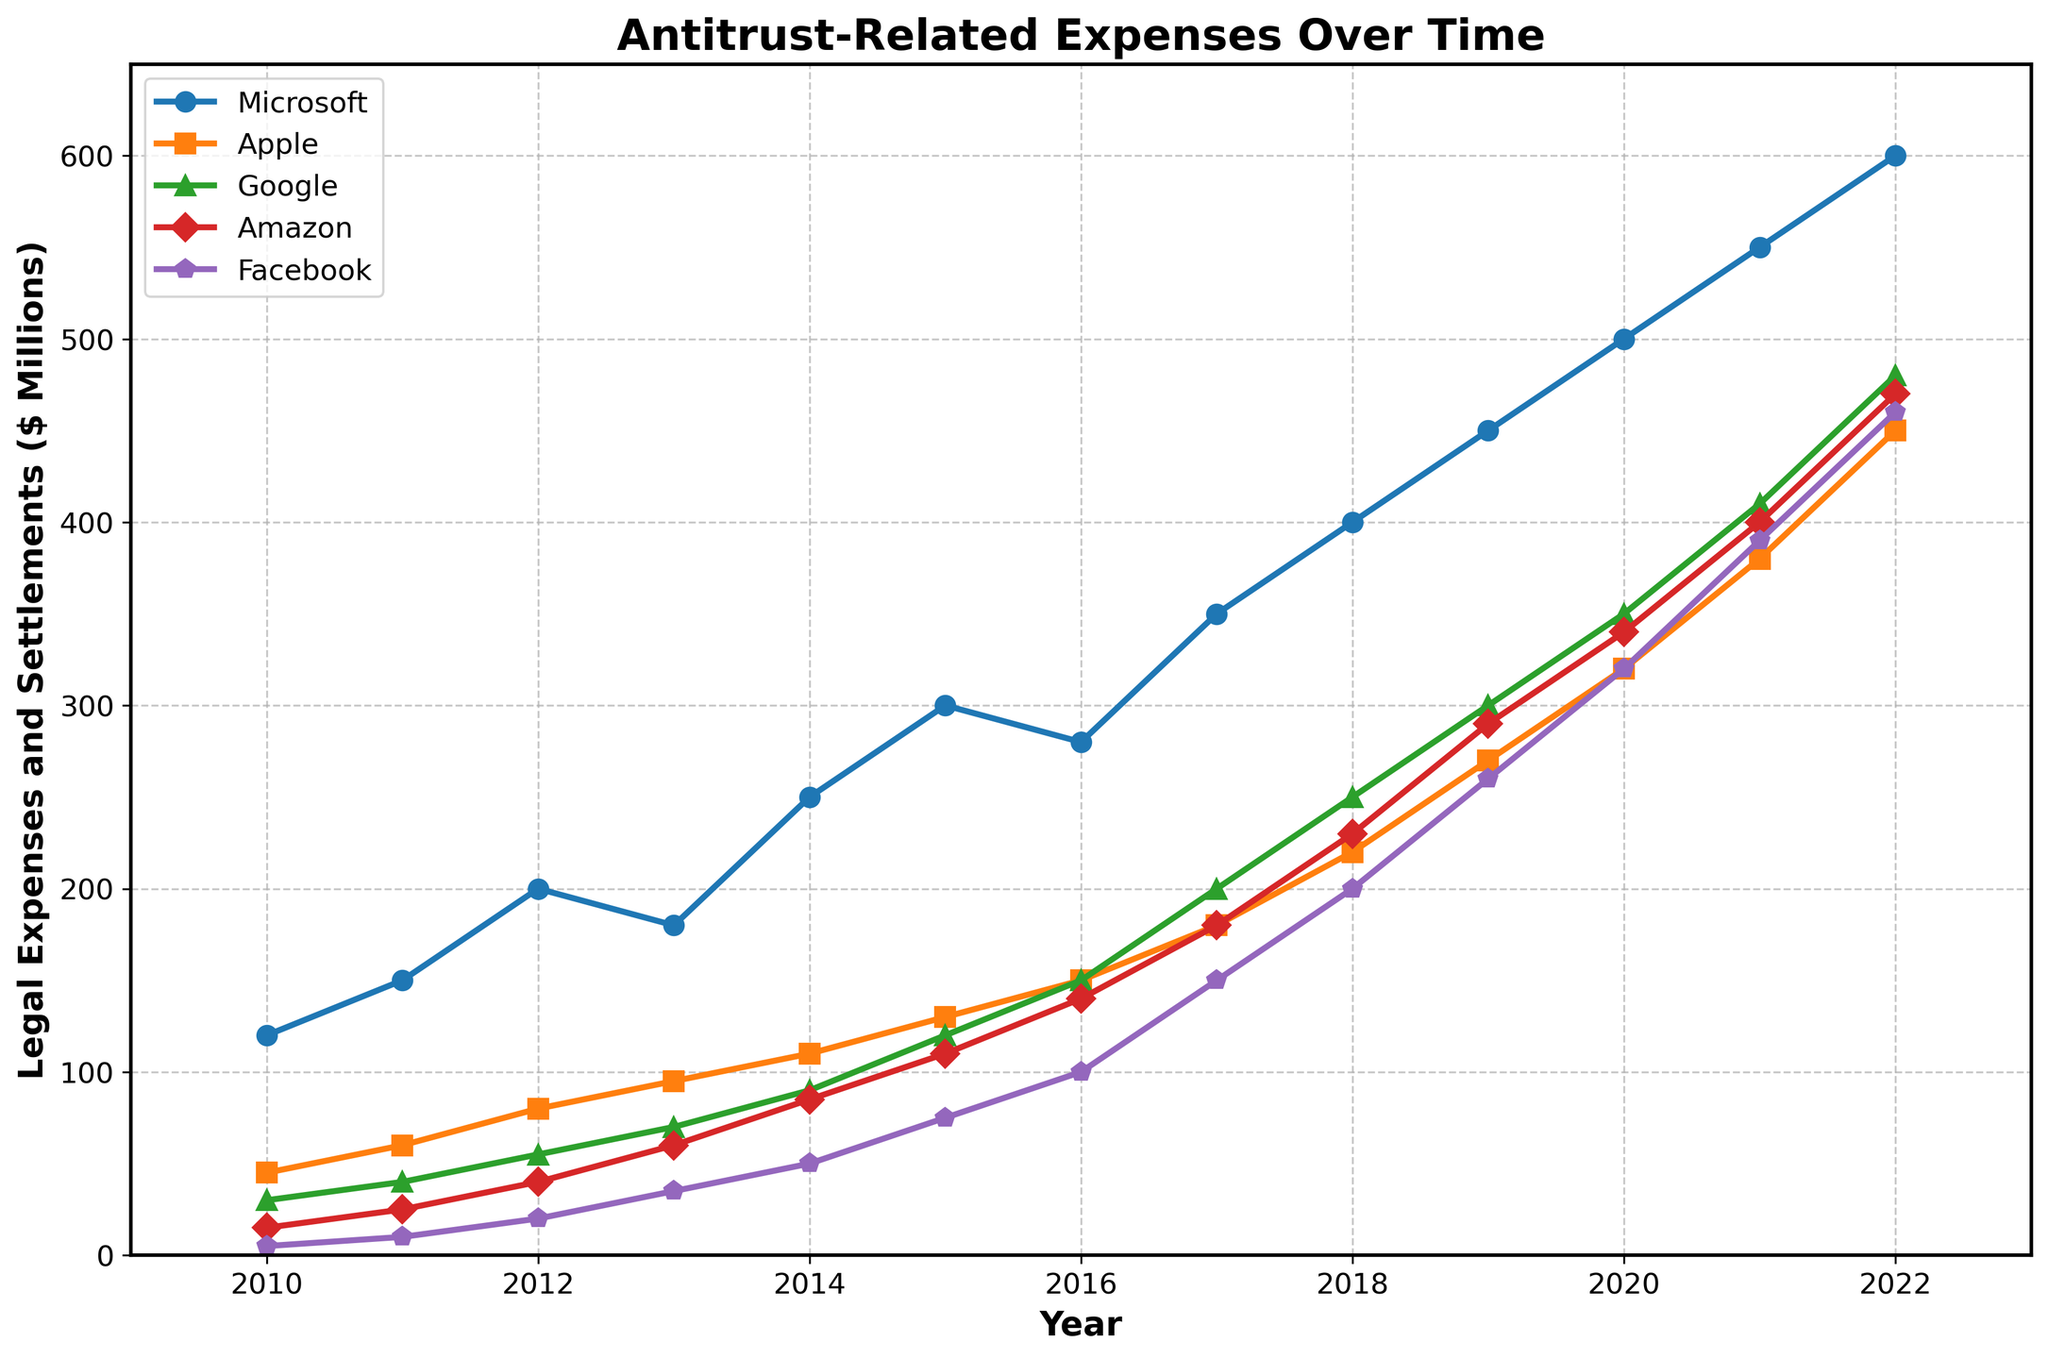What's the trend in Microsoft's antitrust-related expenses between 2010 and 2022? From 2010 to 2022, Microsoft's expenses show a general increasing trend with some fluctuations. Specifically, the expenses increased from 120 million in 2010 to 600 million in 2022, with a spike in 2017 and a visible rise continued up to 2022
Answer: Increasing Which company had the lowest legal expenses in 2020? In 2020, Facebook had the lowest legal expenses at 320 million compared to Microsoft, Apple, Google, and Amazon.
Answer: Facebook What is the difference in legal expenses between Apple and Google in 2015? The legal expenses for Apple in 2015 were 130 million and for Google were 120 million. The difference is 130 - 120 = 10 million.
Answer: 10 million How did Amazon's legal expenses change from 2013 to 2018? Between 2013 and 2018, Amazon's legal expenses increased significantly from 60 million to 230 million, indicating a growth of 230 - 60 = 170 million.
Answer: Increase by 170 million Which company experienced the highest increase in legal expenses from 2019 to 2021? From 2019 to 2021, Google’s expenses grew from 300 million to 410 million, an increase of 110 million. This is the highest increase compared to other companies over the same period.
Answer: Google In which year did Facebook's legal expenses first exceed 100 million? Facebook's legal expenses first exceeded 100 million in the year 2017, where they are recorded at 150 million.
Answer: 2017 Compare the legal expenses of Microsoft and Apple in 2022. In 2022, Microsoft's expenses were 600 million while Apple’s expenses were 450 million. Therefore, Microsoft's expenses were greater.
Answer: Microsoft Calculate the average legal expenses of Google from 2010 to 2015. The average legal expenses for Google between 2010 and 2015 are given by averaging the data points: (30 + 40 + 55 + 70 + 90 + 120) / 6 = 67.5 million.
Answer: 67.5 million Which company showed the most consistent growth in legal expenses over the years? Analyzing the plot, Amazon shows a relatively consistent growth pattern in legal expenses from 2010 to 2022, with a steady increase year by year.
Answer: Amazon 